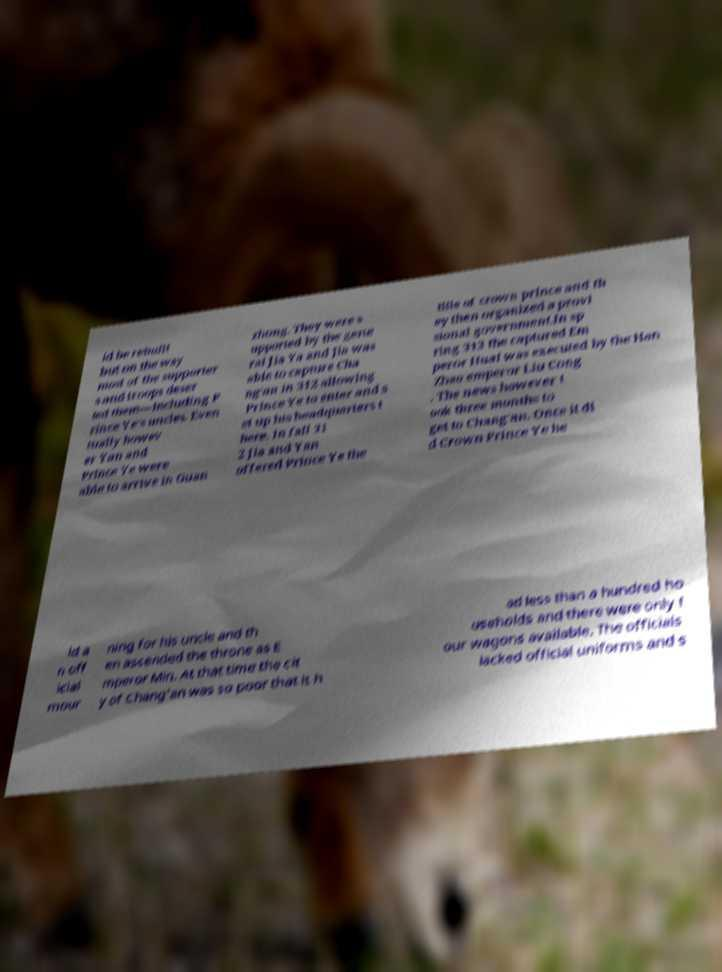Could you assist in decoding the text presented in this image and type it out clearly? ld be rebuilt but on the way most of the supporter s and troops deser ted them—including P rince Ye's uncles. Even tually howev er Yan and Prince Ye were able to arrive in Guan zhong. They were s upported by the gene ral Jia Ya and Jia was able to capture Cha ng'an in 312 allowing Prince Ye to enter and s et up his headquarters t here. In fall 31 2 Jia and Yan offered Prince Ye the title of crown prince and th ey then organized a provi sional government.In sp ring 313 the captured Em peror Huai was executed by the Han Zhao emperor Liu Cong . The news however t ook three months to get to Chang'an. Once it di d Crown Prince Ye he ld a n off icial mour ning for his uncle and th en ascended the throne as E mperor Min. At that time the cit y of Chang'an was so poor that it h ad less than a hundred ho useholds and there were only f our wagons available. The officials lacked official uniforms and s 